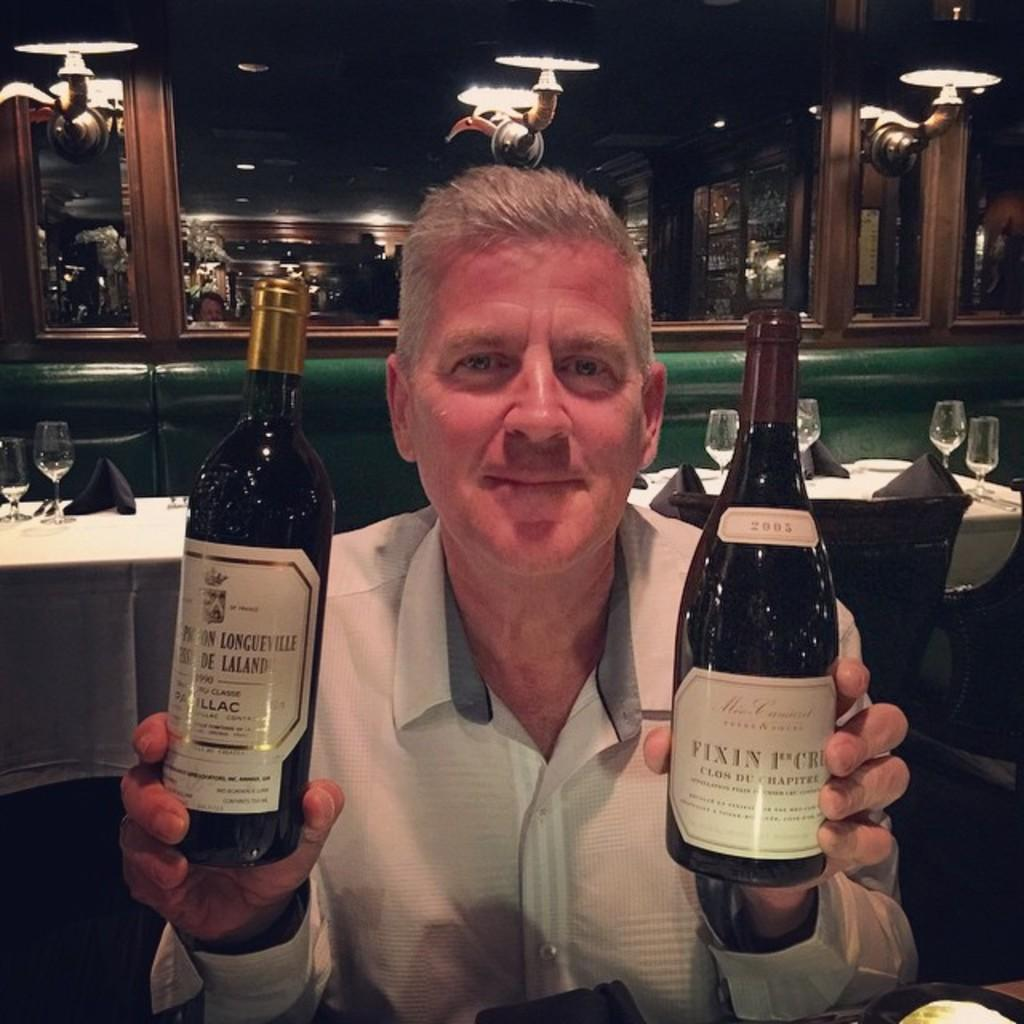<image>
Share a concise interpretation of the image provided. A man holds up two bottles of wine in a restaurant, including a Fixin label bottle. 